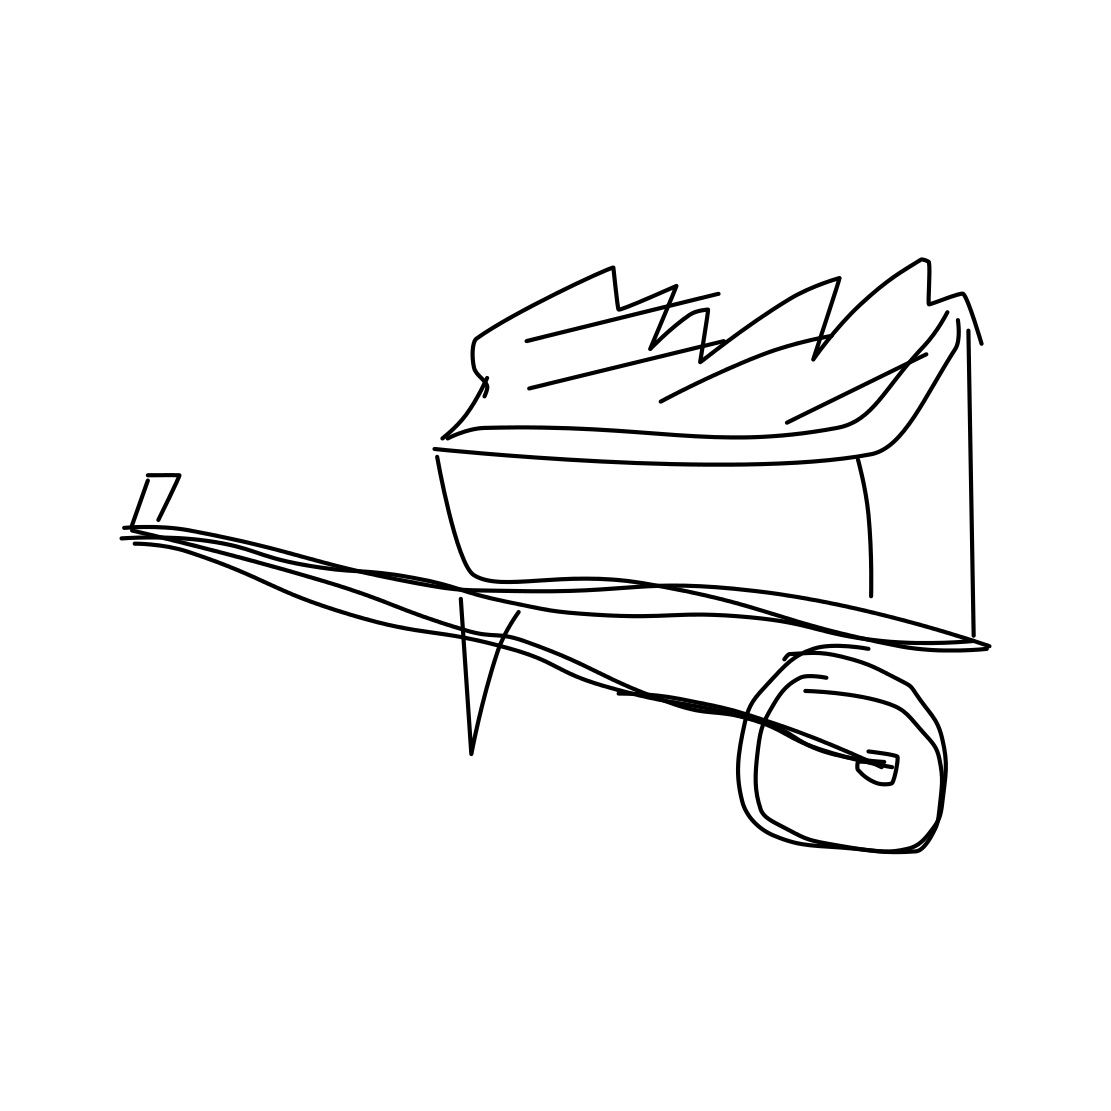Could this image symbolically represent anything in a broader context? Potentially, the overflowing bin might symbolize excess or waste in society, highlighting issues of sustainability and environmental concern. How might this interpretation affect our view of everyday objects? This interpretation could encourage a deeper reflection on our consumption habits and the ecological impacts of our waste, urging a more mindful and sustainable approach to resource usage. 